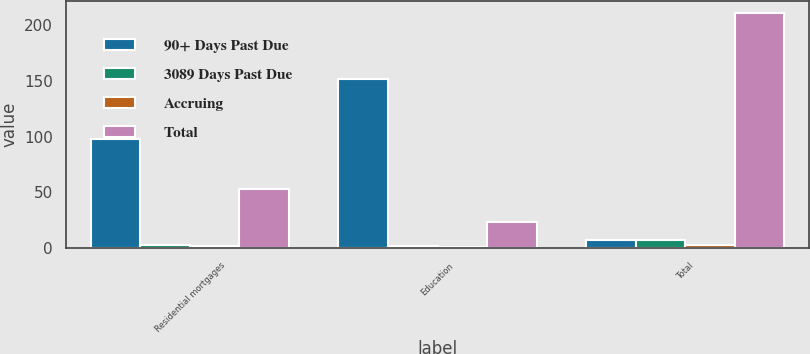Convert chart to OTSL. <chart><loc_0><loc_0><loc_500><loc_500><stacked_bar_chart><ecel><fcel>Residential mortgages<fcel>Education<fcel>Total<nl><fcel>90+ Days Past Due<fcel>98<fcel>152<fcel>6.7<nl><fcel>3089 Days Past Due<fcel>2.7<fcel>1.3<fcel>6.7<nl><fcel>Accruing<fcel>2<fcel>0.5<fcel>2.5<nl><fcel>Total<fcel>53<fcel>23<fcel>211<nl></chart> 